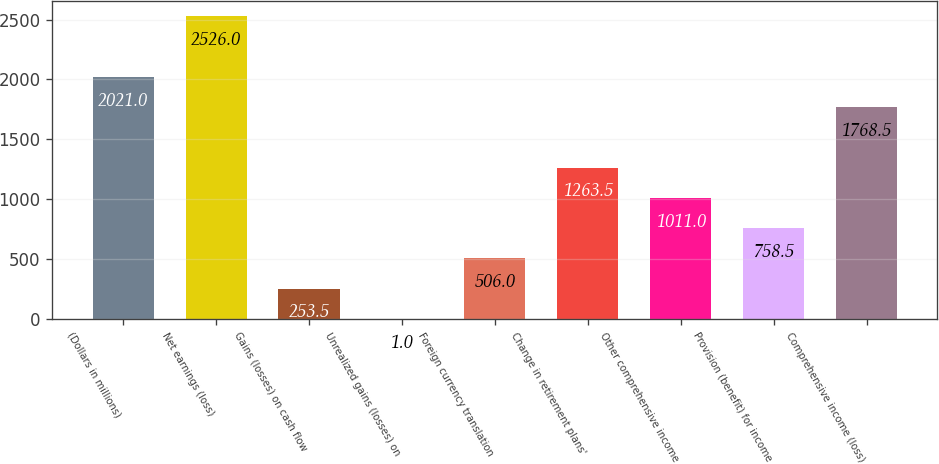Convert chart to OTSL. <chart><loc_0><loc_0><loc_500><loc_500><bar_chart><fcel>(Dollars in millions)<fcel>Net earnings (loss)<fcel>Gains (losses) on cash flow<fcel>Unrealized gains (losses) on<fcel>Foreign currency translation<fcel>Change in retirement plans'<fcel>Other comprehensive income<fcel>Provision (benefit) for income<fcel>Comprehensive income (loss)<nl><fcel>2021<fcel>2526<fcel>253.5<fcel>1<fcel>506<fcel>1263.5<fcel>1011<fcel>758.5<fcel>1768.5<nl></chart> 